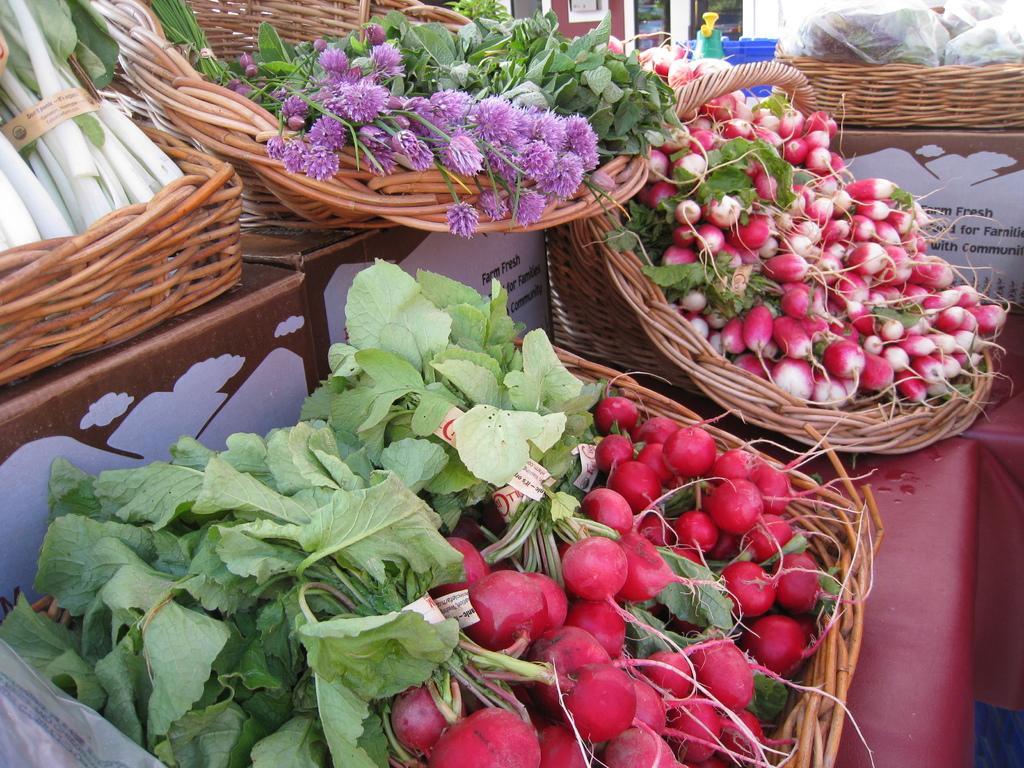Describe this image in one or two sentences. In this picture I can see vegetables on the trays, there are cardboard boxes, and in the background there are some objects. 